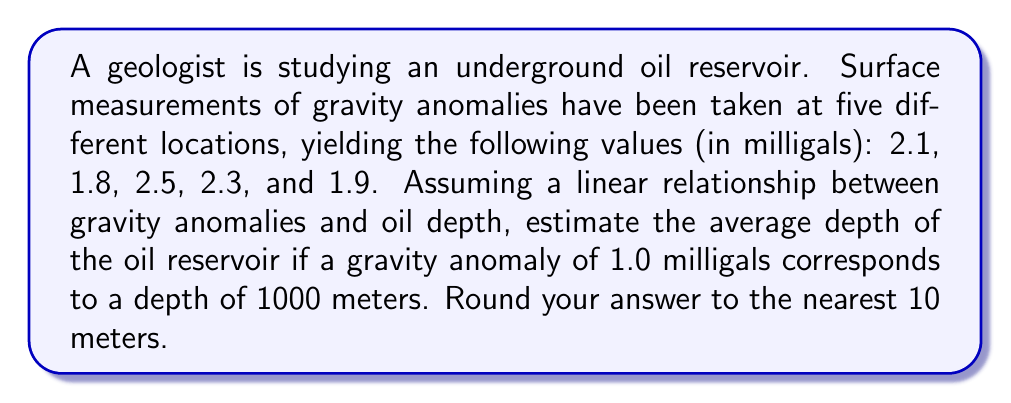Give your solution to this math problem. Let's approach this step-by-step:

1) First, we need to calculate the average gravity anomaly from the given measurements:

   $\text{Average} = \frac{2.1 + 1.8 + 2.5 + 2.3 + 1.9}{5} = \frac{10.6}{5} = 2.12$ milligals

2) Now, we know that:
   - 1.0 milligals corresponds to 1000 meters
   - 2.12 milligals corresponds to our unknown depth

3) We can set up a proportion:

   $\frac{1.0 \text{ milligals}}{1000 \text{ meters}} = \frac{2.12 \text{ milligals}}{x \text{ meters}}$

4) Cross multiply:

   $1.0x = 2.12 \cdot 1000$

5) Solve for x:

   $x = \frac{2.12 \cdot 1000}{1.0} = 2120$ meters

6) Rounding to the nearest 10 meters:

   2120 meters rounds to 2120 meters

Therefore, the estimated average depth of the oil reservoir is 2120 meters.
Answer: 2120 meters 